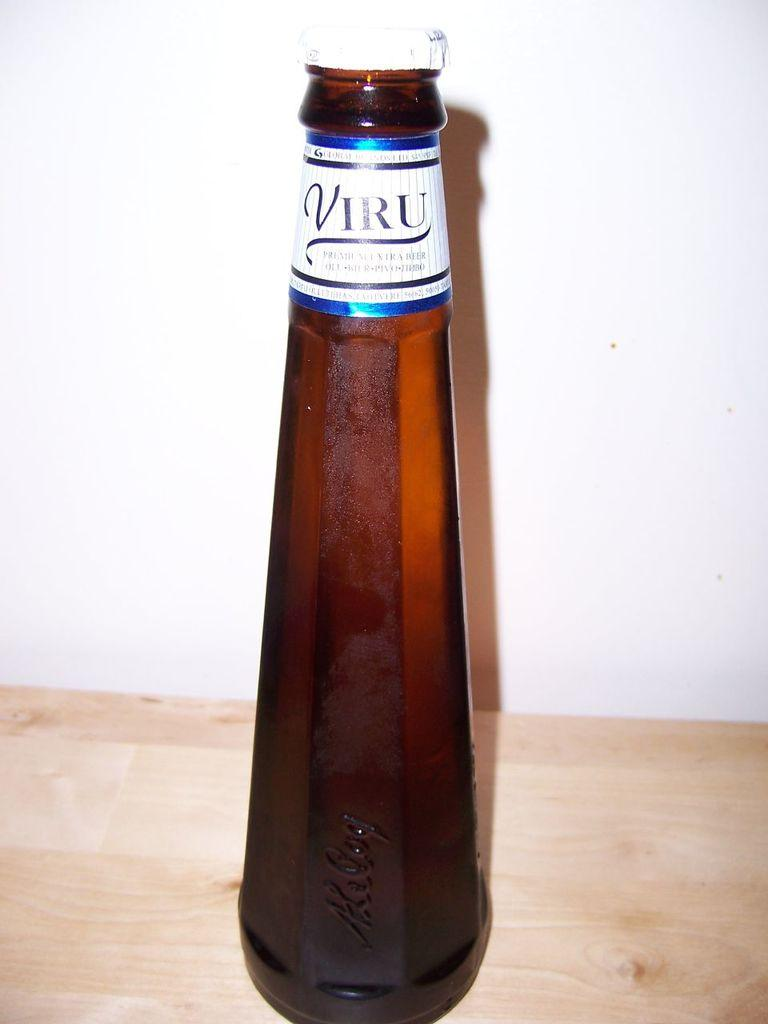<image>
Relay a brief, clear account of the picture shown. A bottle of premium Viru beer sits on a piece of raw wood. 